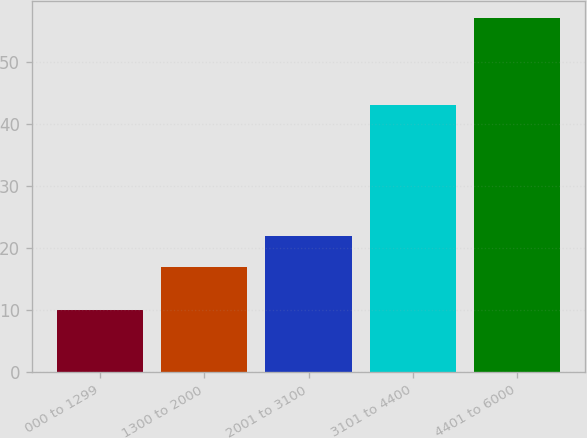Convert chart to OTSL. <chart><loc_0><loc_0><loc_500><loc_500><bar_chart><fcel>000 to 1299<fcel>1300 to 2000<fcel>2001 to 3100<fcel>3101 to 4400<fcel>4401 to 6000<nl><fcel>10<fcel>17<fcel>22<fcel>43<fcel>57<nl></chart> 